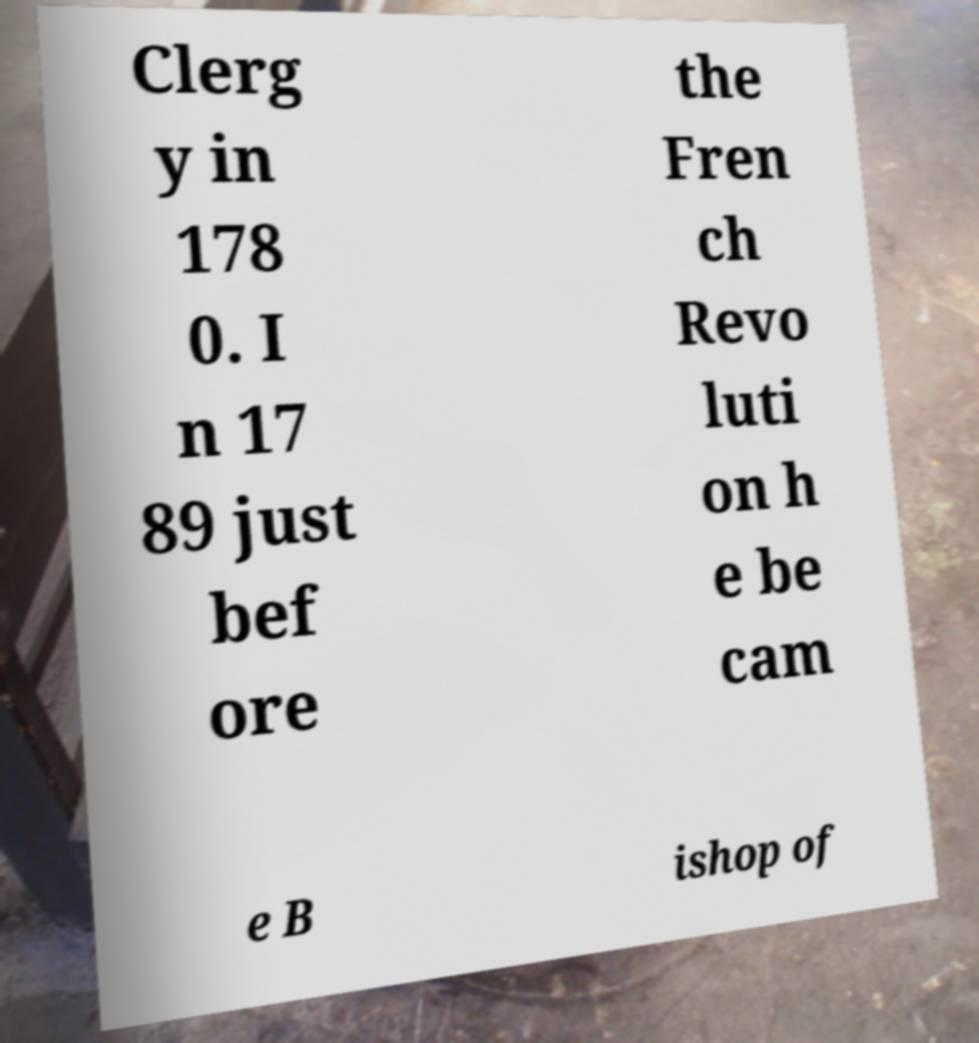Could you assist in decoding the text presented in this image and type it out clearly? Clerg y in 178 0. I n 17 89 just bef ore the Fren ch Revo luti on h e be cam e B ishop of 